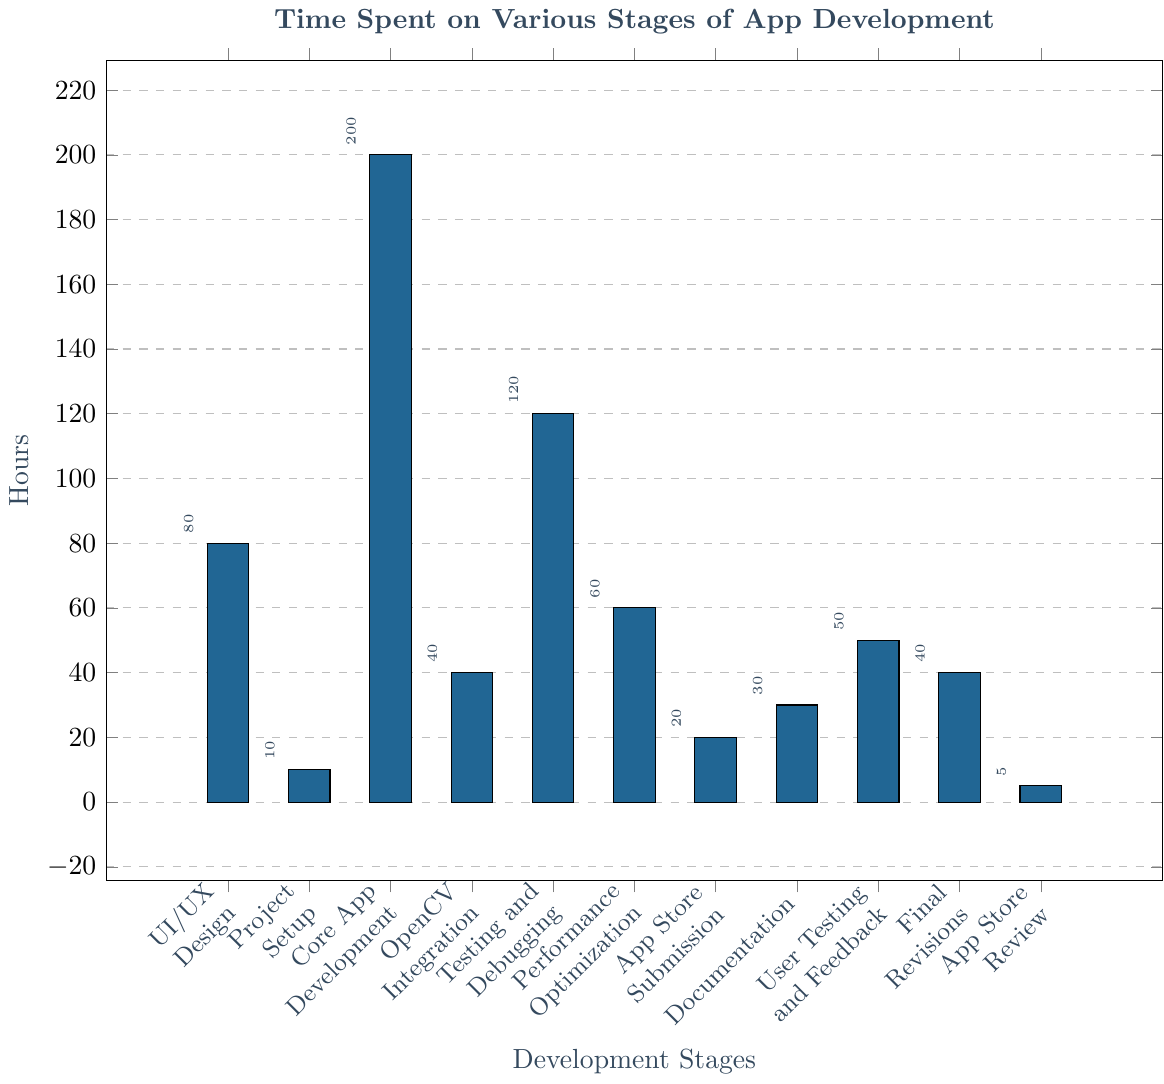What is the total time spent on 'UI/UX Design' and 'Core App Development'? The hours spent on 'UI/UX Design' is 80, and for 'Core App Development' is 200. Adding these two gives 80 + 200 = 280 hours.
Answer: 280 Which stage took more time: 'Testing and Debugging' or 'Performance Optimization'? The time spent on 'Testing and Debugging' is 120 hours, while 'Performance Optimization' took 60 hours. Since 120 is greater than 60, 'Testing and Debugging' took more time.
Answer: Testing and Debugging What is the average time spent on 'OpenCV Integration' and 'Final Revisions'? The time spent on 'OpenCV Integration' is 40 hours, and 'Final Revisions' is also 40 hours. The average is calculated as (40 + 40) / 2 = 40 hours.
Answer: 40 Which stage had the least time spent on it? Observing all the bars, 'App Store Review Process' has the smallest bar height corresponding to 5 hours.
Answer: App Store Review Process How much more time was spent on 'Performance Optimization' compared to 'App Store Submission Preparation'? The hours spent on 'Performance Optimization' is 60, and 'App Store Submission Preparation' is 20. The difference is 60 - 20 = 40 hours.
Answer: 40 If you combine 'Documentation' and 'User Testing and Feedback', do they take more or less time than 'Testing and Debugging'? 'Documentation' took 30 hours and 'User Testing and Feedback' took 50 hours, summing up to 30 + 50 = 80 hours. 'Testing and Debugging' took 120 hours, so 80 is less than 120.
Answer: Less Compare the time spent on 'Project Setup in Xcode' and 'Final Revisions'. Are they equal? 'Project Setup in Xcode' takes 10 hours while 'Final Revisions' takes 40 hours. Since 10 and 40 are not equal, they aren't equal.
Answer: No What is the total time spent on 'User Testing and Feedback' and 'UI/UX Design'? The hours spent on 'User Testing and Feedback' are 50 and 'UI/UX Design' are 80. Adding them together gives 50 + 80 = 130 hours.
Answer: 130 By how many hours does 'Core App Development' exceed 'OpenCV Integration'? 'Core App Development' took 200 hours and 'OpenCV Integration' took 40 hours. The difference is 200 - 40 = 160 hours.
Answer: 160 